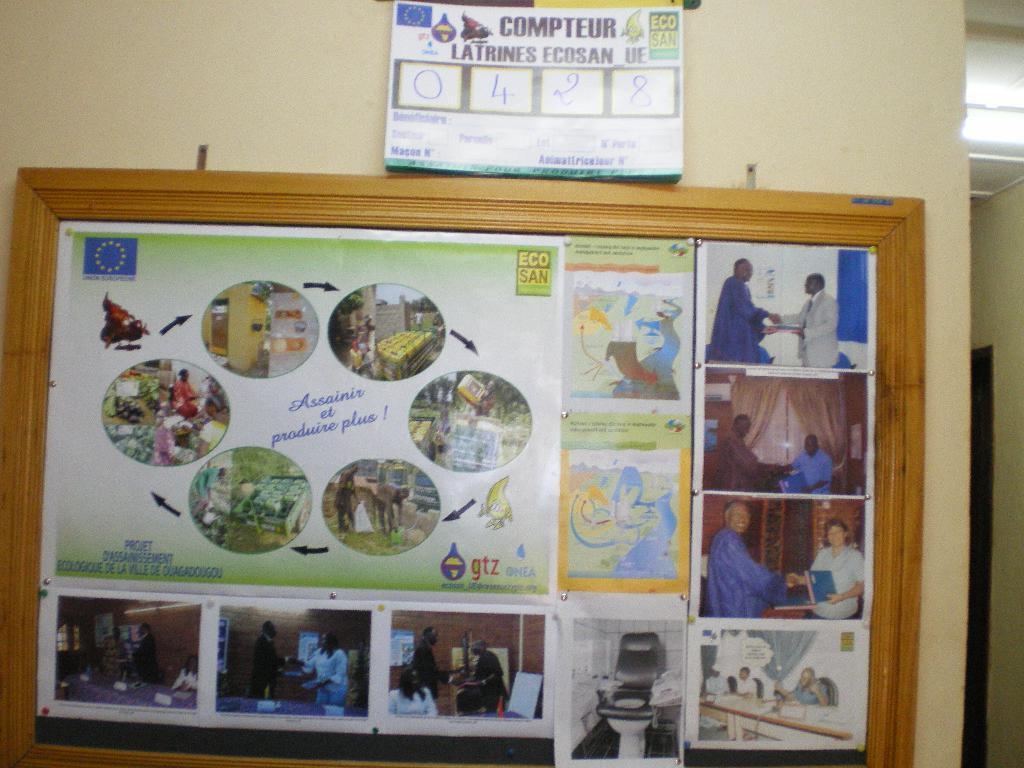Could you give a brief overview of what you see in this image? In the image there is a notice board attached to the wall and on the notice board there are posters and pictures and there is some poster attached to the wall above the notice board. 